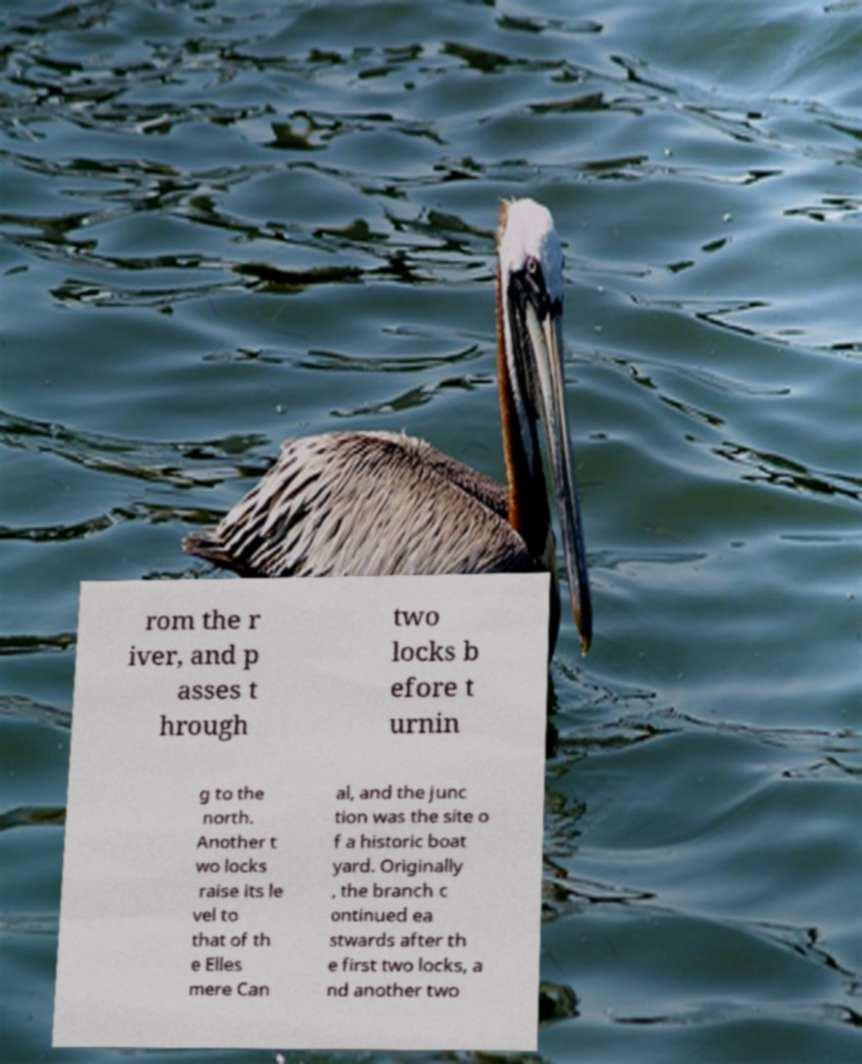Could you assist in decoding the text presented in this image and type it out clearly? rom the r iver, and p asses t hrough two locks b efore t urnin g to the north. Another t wo locks raise its le vel to that of th e Elles mere Can al, and the junc tion was the site o f a historic boat yard. Originally , the branch c ontinued ea stwards after th e first two locks, a nd another two 